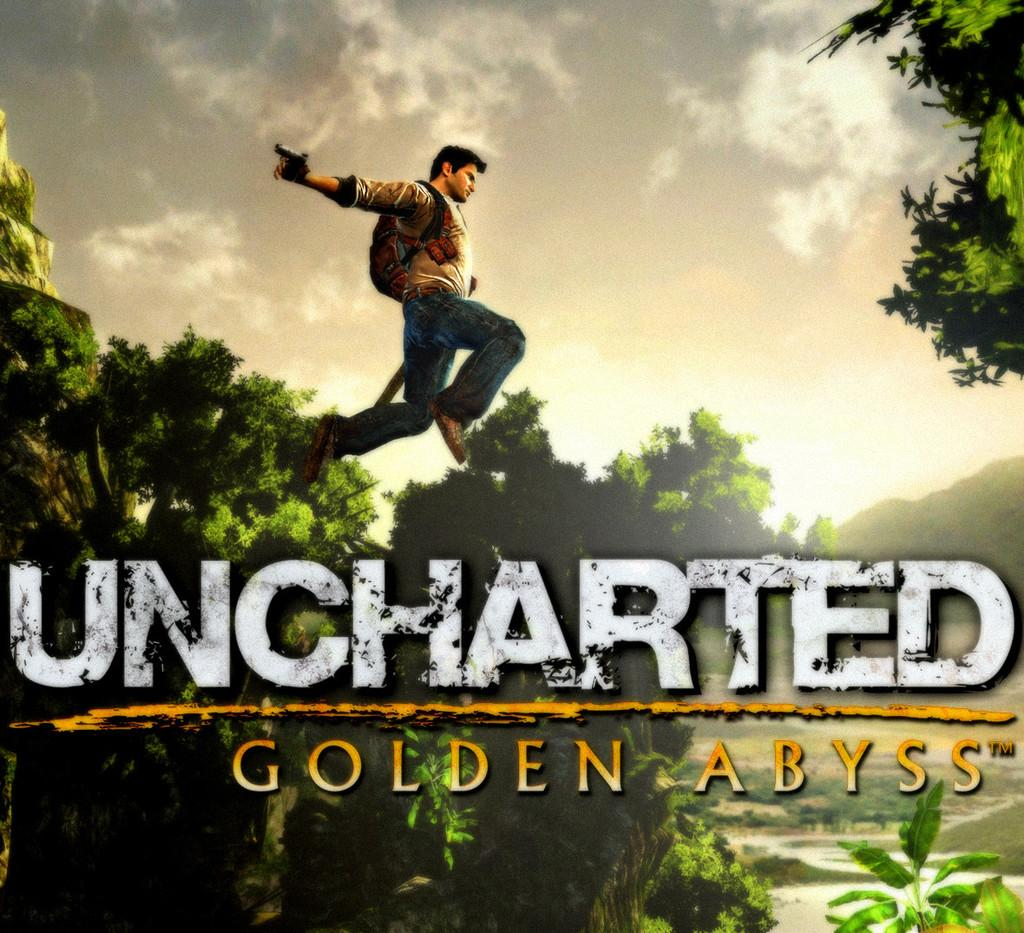What type of image is being described? The image is animated. What can be seen in the background of the image? There are trees and a hill in the image. What is the weather like in the image? The sky in the image is cloudy. What is the person in the image doing? The person is in the air and holding a gun. What is the person wearing in the image? The person is wearing a bag. Is there any text present in the image? Yes, there is text written on the image. What type of wrench is the minister using to stretch the hill in the image? There is no minister, wrench, or hill-stretching activity present in the image. 